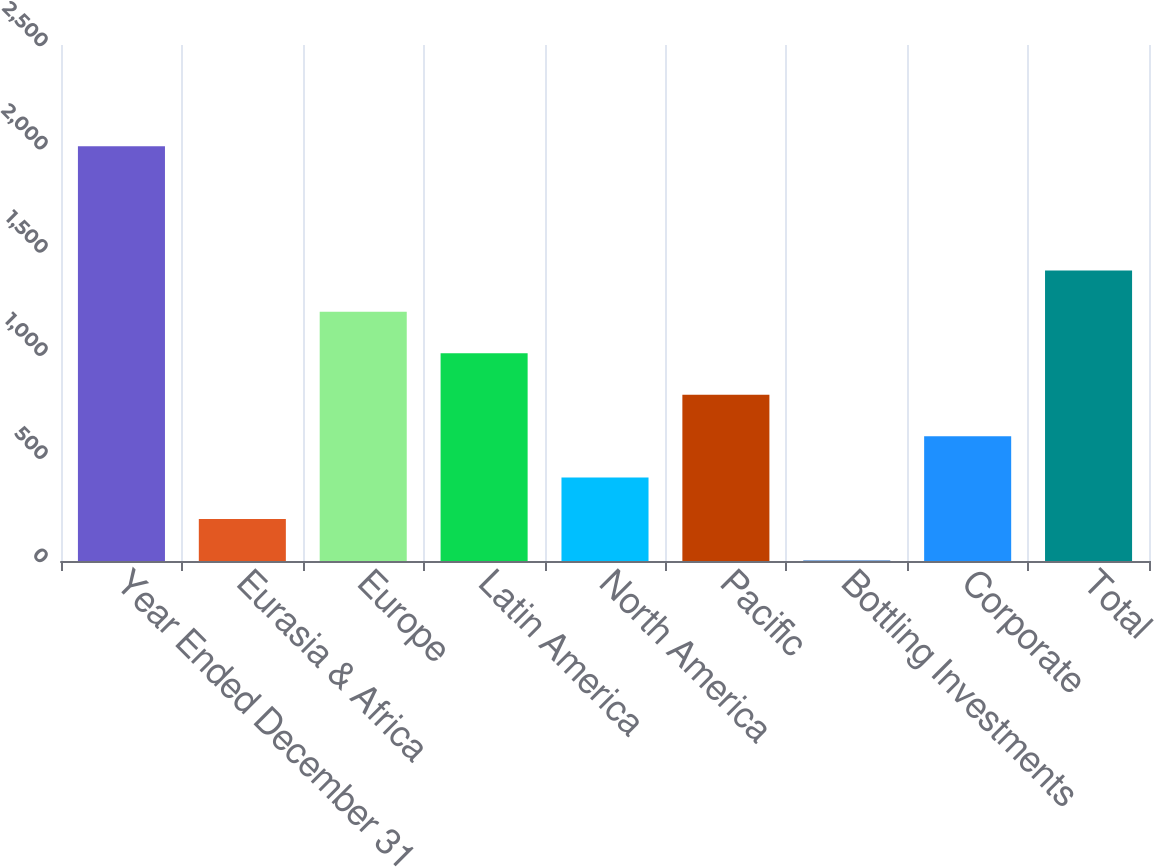Convert chart. <chart><loc_0><loc_0><loc_500><loc_500><bar_chart><fcel>Year Ended December 31<fcel>Eurasia & Africa<fcel>Europe<fcel>Latin America<fcel>North America<fcel>Pacific<fcel>Bottling Investments<fcel>Corporate<fcel>Total<nl><fcel>2010<fcel>203.43<fcel>1207.08<fcel>1006.35<fcel>404.16<fcel>805.62<fcel>2.7<fcel>604.89<fcel>1407.81<nl></chart> 